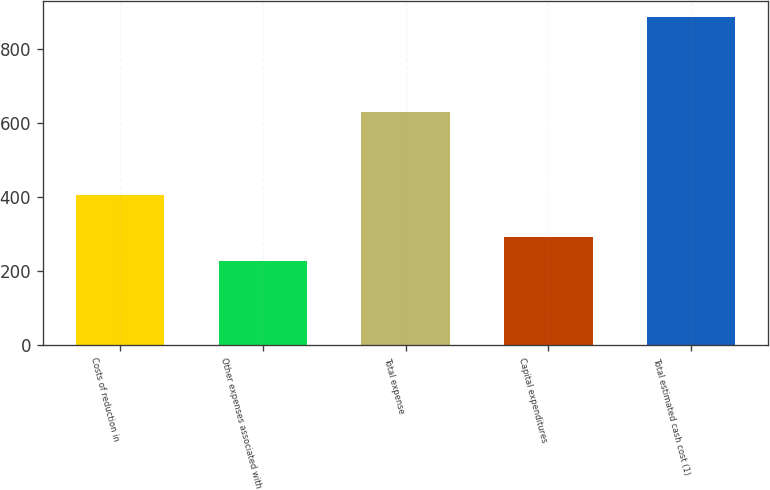Convert chart to OTSL. <chart><loc_0><loc_0><loc_500><loc_500><bar_chart><fcel>Costs of reduction in<fcel>Other expenses associated with<fcel>Total expense<fcel>Capital expenditures<fcel>Total estimated cash cost (1)<nl><fcel>405<fcel>225<fcel>630<fcel>291<fcel>885<nl></chart> 